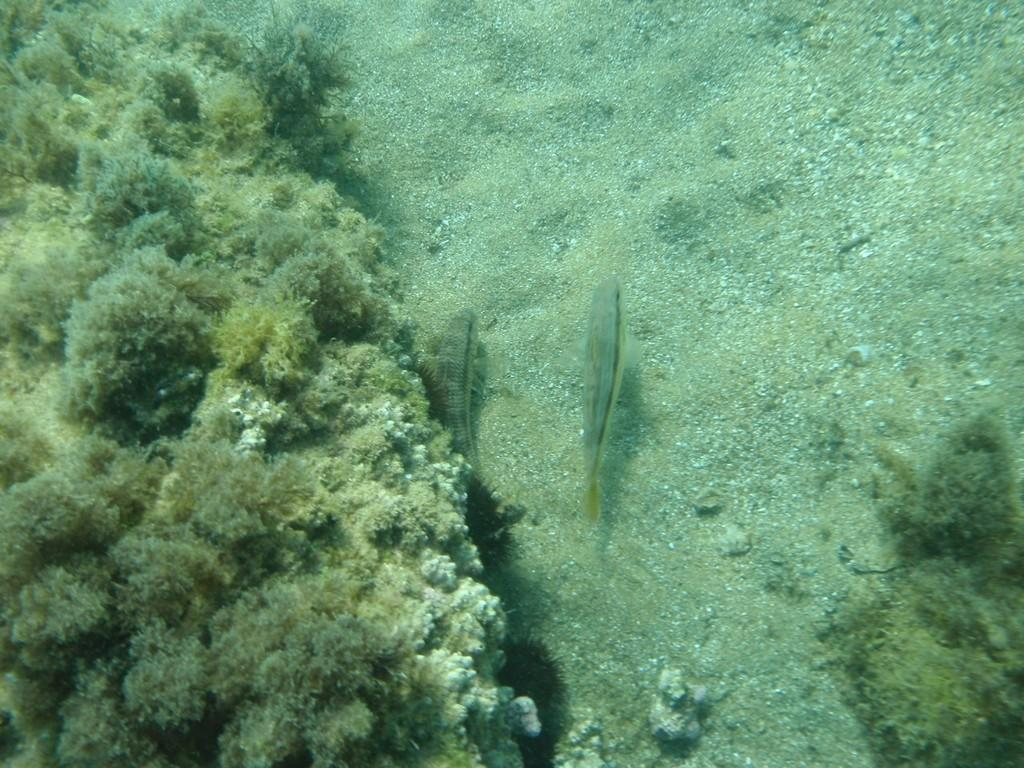What animals can be seen in the image? There are two fishes in the image. Where are the fishes located? The fishes are in the underwater. What type of surface is around the fishes? There is sand around the fishes. What else can be seen around the fishes? There are plants around the fishes. What type of spring is visible in the image? There is no spring present in the image; it features two fishes in the underwater with sand and plants around them. 